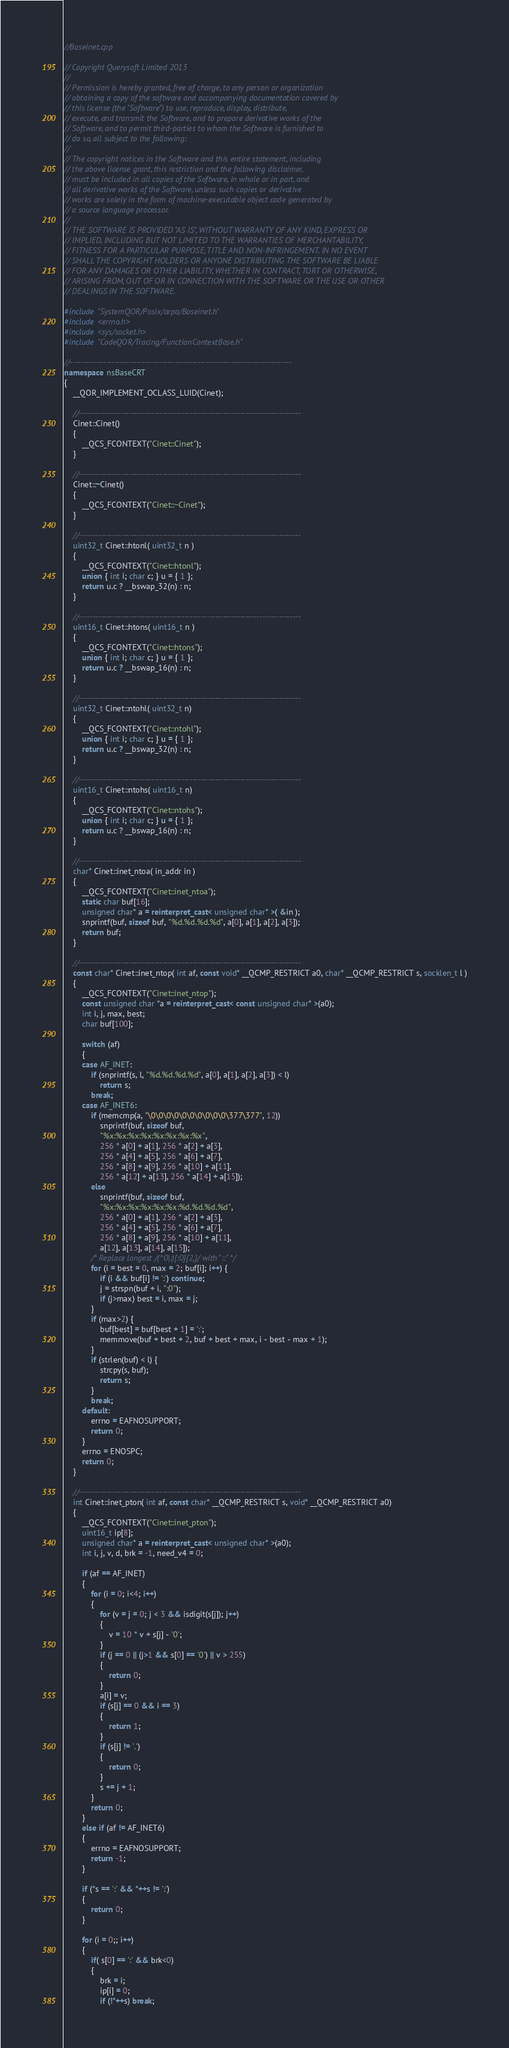Convert code to text. <code><loc_0><loc_0><loc_500><loc_500><_C++_>//Baseinet.cpp

// Copyright Querysoft Limited 2013
//
// Permission is hereby granted, free of charge, to any person or organization
// obtaining a copy of the software and accompanying documentation covered by
// this license (the "Software") to use, reproduce, display, distribute,
// execute, and transmit the Software, and to prepare derivative works of the
// Software, and to permit third-parties to whom the Software is furnished to
// do so, all subject to the following:
//
// The copyright notices in the Software and this entire statement, including
// the above license grant, this restriction and the following disclaimer,
// must be included in all copies of the Software, in whole or in part, and
// all derivative works of the Software, unless such copies or derivative
// works are solely in the form of machine-executable object code generated by
// a source language processor.
//
// THE SOFTWARE IS PROVIDED "AS IS", WITHOUT WARRANTY OF ANY KIND, EXPRESS OR
// IMPLIED, INCLUDING BUT NOT LIMITED TO THE WARRANTIES OF MERCHANTABILITY,
// FITNESS FOR A PARTICULAR PURPOSE, TITLE AND NON-INFRINGEMENT. IN NO EVENT
// SHALL THE COPYRIGHT HOLDERS OR ANYONE DISTRIBUTING THE SOFTWARE BE LIABLE
// FOR ANY DAMAGES OR OTHER LIABILITY, WHETHER IN CONTRACT, TORT OR OTHERWISE,
// ARISING FROM, OUT OF OR IN CONNECTION WITH THE SOFTWARE OR THE USE OR OTHER
// DEALINGS IN THE SOFTWARE.

#include "SystemQOR/Posix/arpa/Baseinet.h"
#include <errno.h>
#include <sys/socket.h>
#include "CodeQOR/Tracing/FunctionContextBase.h"

//--------------------------------------------------------------------------------
namespace nsBaseCRT
{
	__QOR_IMPLEMENT_OCLASS_LUID(Cinet);

	//--------------------------------------------------------------------------------
	Cinet::Cinet()
	{
		__QCS_FCONTEXT("Cinet::Cinet");
	}

	//--------------------------------------------------------------------------------
	Cinet::~Cinet()
	{
		__QCS_FCONTEXT("Cinet::~Cinet");
	}

	//--------------------------------------------------------------------------------
    uint32_t Cinet::htonl( uint32_t n )
	{
		__QCS_FCONTEXT("Cinet::htonl");
		union { int i; char c; } u = { 1 };
		return u.c ? __bswap_32(n) : n;
	}

	//--------------------------------------------------------------------------------
    uint16_t Cinet::htons( uint16_t n )
	{
		__QCS_FCONTEXT("Cinet::htons");
		union { int i; char c; } u = { 1 };
		return u.c ? __bswap_16(n) : n;
	}

	//--------------------------------------------------------------------------------
    uint32_t Cinet::ntohl( uint32_t n)
	{
		__QCS_FCONTEXT("Cinet::ntohl");
		union { int i; char c; } u = { 1 };
		return u.c ? __bswap_32(n) : n;
	}

	//--------------------------------------------------------------------------------
    uint16_t Cinet::ntohs( uint16_t n)
	{
		__QCS_FCONTEXT("Cinet::ntohs");
		union { int i; char c; } u = { 1 };
		return u.c ? __bswap_16(n) : n;
	}

	//--------------------------------------------------------------------------------
    char* Cinet::inet_ntoa( in_addr in )
	{
		__QCS_FCONTEXT("Cinet::inet_ntoa");
		static char buf[16];
		unsigned char* a = reinterpret_cast< unsigned char* >( &in );
		snprintf(buf, sizeof buf, "%d.%d.%d.%d", a[0], a[1], a[2], a[3]);
		return buf;
	}

	//--------------------------------------------------------------------------------
    const char* Cinet::inet_ntop( int af, const void* __QCMP_RESTRICT a0, char* __QCMP_RESTRICT s, socklen_t l )
	{
		__QCS_FCONTEXT("Cinet::inet_ntop");
		const unsigned char *a = reinterpret_cast< const unsigned char* >(a0);
		int i, j, max, best;
		char buf[100];

		switch (af)
		{
		case AF_INET:
			if (snprintf(s, l, "%d.%d.%d.%d", a[0], a[1], a[2], a[3]) < l)
				return s;
			break;
		case AF_INET6:
			if (memcmp(a, "\0\0\0\0\0\0\0\0\0\0\377\377", 12))
				snprintf(buf, sizeof buf,
				"%x:%x:%x:%x:%x:%x:%x:%x",
				256 * a[0] + a[1], 256 * a[2] + a[3],
				256 * a[4] + a[5], 256 * a[6] + a[7],
				256 * a[8] + a[9], 256 * a[10] + a[11],
				256 * a[12] + a[13], 256 * a[14] + a[15]);
			else
				snprintf(buf, sizeof buf,
				"%x:%x:%x:%x:%x:%x:%d.%d.%d.%d",
				256 * a[0] + a[1], 256 * a[2] + a[3],
				256 * a[4] + a[5], 256 * a[6] + a[7],
				256 * a[8] + a[9], 256 * a[10] + a[11],
				a[12], a[13], a[14], a[15]);
			/* Replace longest /(^0|:)[:0]{2,}/ with "::" */
			for (i = best = 0, max = 2; buf[i]; i++) {
				if (i && buf[i] != ':') continue;
				j = strspn(buf + i, ":0");
				if (j>max) best = i, max = j;
			}
			if (max>2) {
				buf[best] = buf[best + 1] = ':';
				memmove(buf + best + 2, buf + best + max, i - best - max + 1);
			}
			if (strlen(buf) < l) {
				strcpy(s, buf);
				return s;
			}
			break;
		default:
			errno = EAFNOSUPPORT;
			return 0;
		}
		errno = ENOSPC;
		return 0;
	}

	//--------------------------------------------------------------------------------
    int Cinet::inet_pton( int af, const char* __QCMP_RESTRICT s, void* __QCMP_RESTRICT a0)
	{
		__QCS_FCONTEXT("Cinet::inet_pton");
		uint16_t ip[8];
		unsigned char* a = reinterpret_cast< unsigned char* >(a0);
		int i, j, v, d, brk = -1, need_v4 = 0;

		if (af == AF_INET)
		{
			for (i = 0; i<4; i++)
			{
				for (v = j = 0; j < 3 && isdigit(s[j]); j++)
				{
					v = 10 * v + s[j] - '0';
				}
				if (j == 0 || (j>1 && s[0] == '0') || v > 255)
				{
					return 0;
				}
				a[i] = v;
				if (s[j] == 0 && i == 3)
				{
					return 1;
				}
				if (s[j] != '.')
				{
					return 0;
				}
				s += j + 1;
			}
			return 0;
		}
		else if (af != AF_INET6)
		{
			errno = EAFNOSUPPORT;
			return -1;
		}

		if (*s == ':' && *++s != ':')
		{
			return 0;
		}

		for (i = 0;; i++)
		{
			if( s[0] == ':' && brk<0)
			{
				brk = i;
				ip[i] = 0;
				if (!*++s) break;</code> 